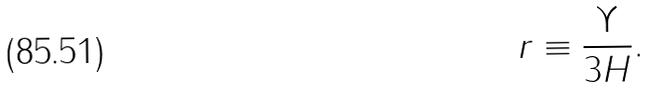<formula> <loc_0><loc_0><loc_500><loc_500>r \equiv \frac { \Upsilon } { 3 H } .</formula> 